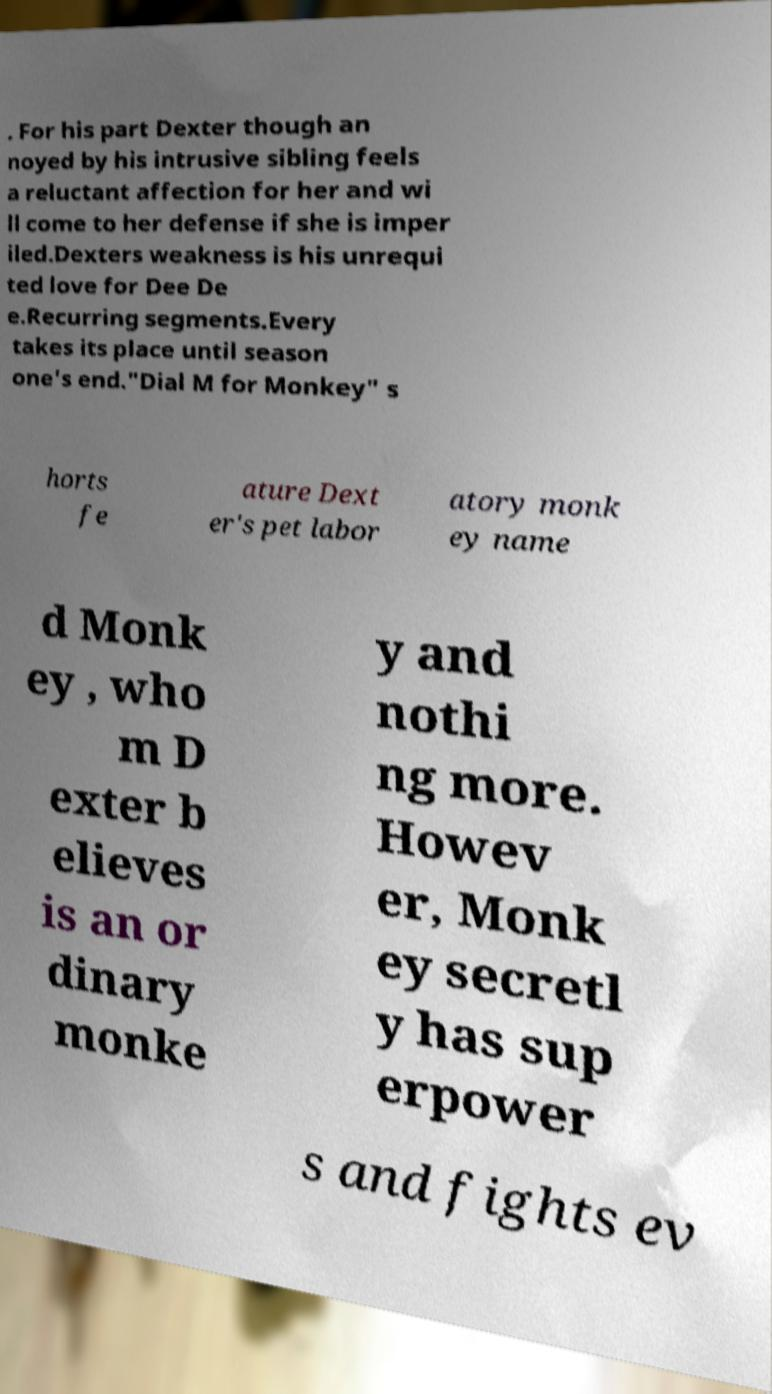For documentation purposes, I need the text within this image transcribed. Could you provide that? . For his part Dexter though an noyed by his intrusive sibling feels a reluctant affection for her and wi ll come to her defense if she is imper iled.Dexters weakness is his unrequi ted love for Dee De e.Recurring segments.Every takes its place until season one's end."Dial M for Monkey" s horts fe ature Dext er's pet labor atory monk ey name d Monk ey , who m D exter b elieves is an or dinary monke y and nothi ng more. Howev er, Monk ey secretl y has sup erpower s and fights ev 